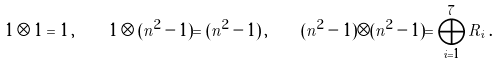Convert formula to latex. <formula><loc_0><loc_0><loc_500><loc_500>1 \otimes 1 = 1 \, , \quad 1 \otimes ( n ^ { 2 } - 1 ) = ( n ^ { 2 } - 1 ) \, , \quad ( n ^ { 2 } - 1 ) \otimes ( n ^ { 2 } - 1 ) = \bigoplus _ { i = 1 } ^ { 7 } R _ { i } \, .</formula> 